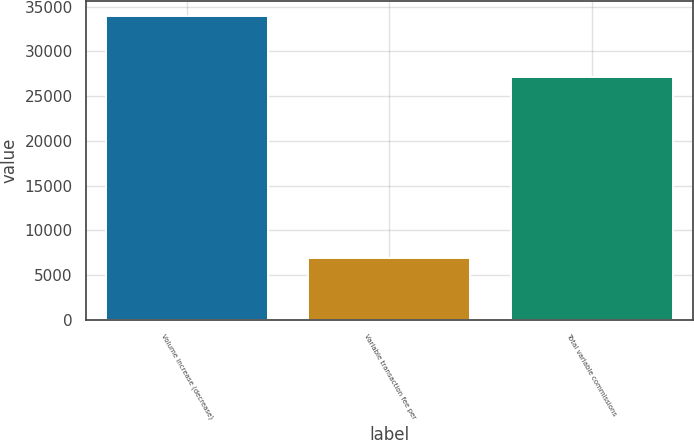Convert chart to OTSL. <chart><loc_0><loc_0><loc_500><loc_500><bar_chart><fcel>Volume increase (decrease)<fcel>Variable transaction fee per<fcel>Total variable commissions<nl><fcel>33993<fcel>6853<fcel>27140<nl></chart> 